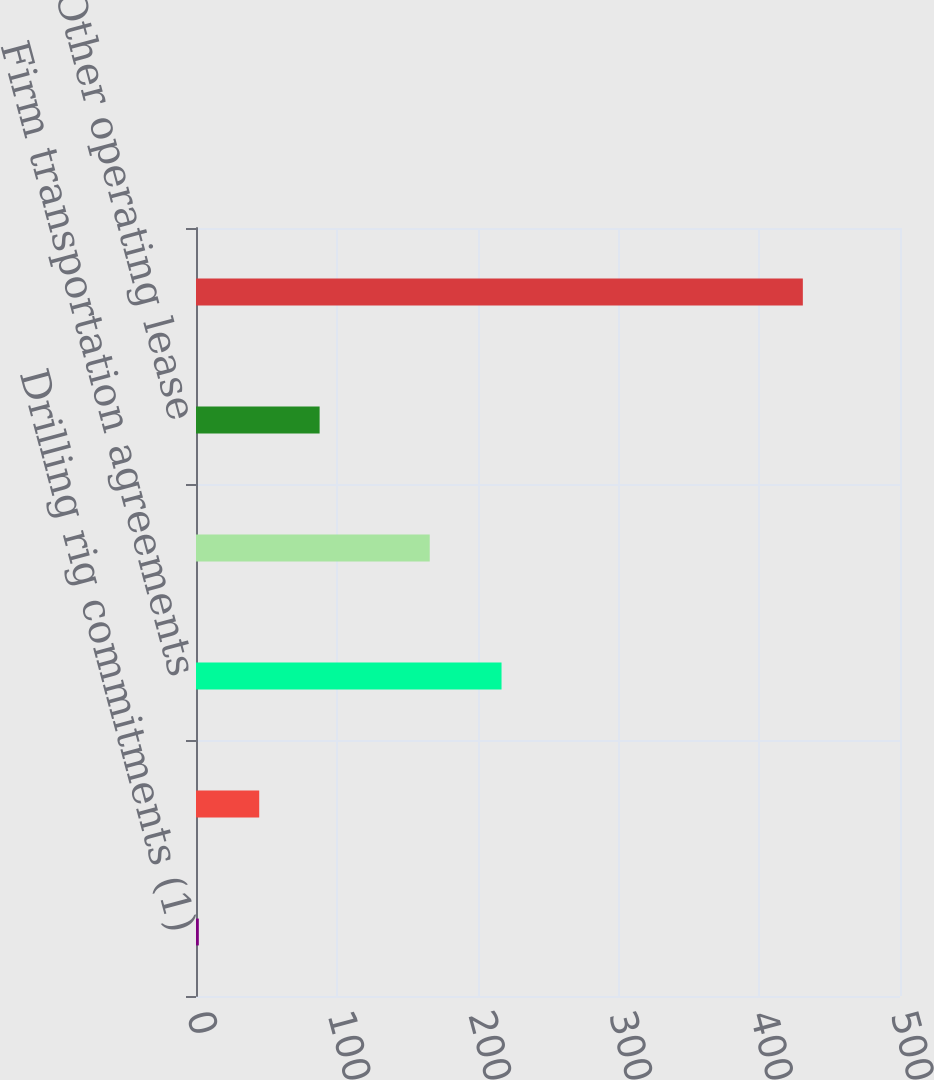<chart> <loc_0><loc_0><loc_500><loc_500><bar_chart><fcel>Drilling rig commitments (1)<fcel>Purchase obligations (2)<fcel>Firm transportation agreements<fcel>Office and related equipment<fcel>Other operating lease<fcel>Total Net Minimum Commitments<nl><fcel>2<fcel>44.9<fcel>217<fcel>166<fcel>87.8<fcel>431<nl></chart> 